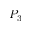Convert formula to latex. <formula><loc_0><loc_0><loc_500><loc_500>P _ { 3 }</formula> 